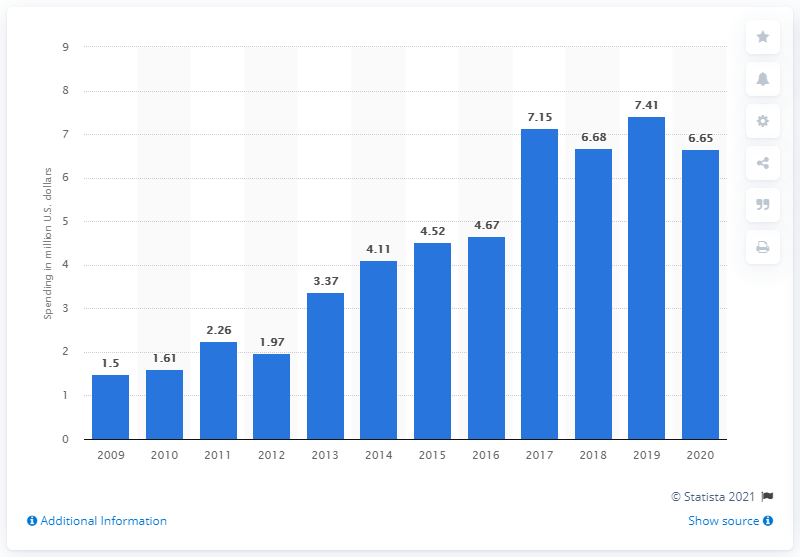Indicate a few pertinent items in this graphic. Apple spent $6.65 million on lobbying in 2020. 